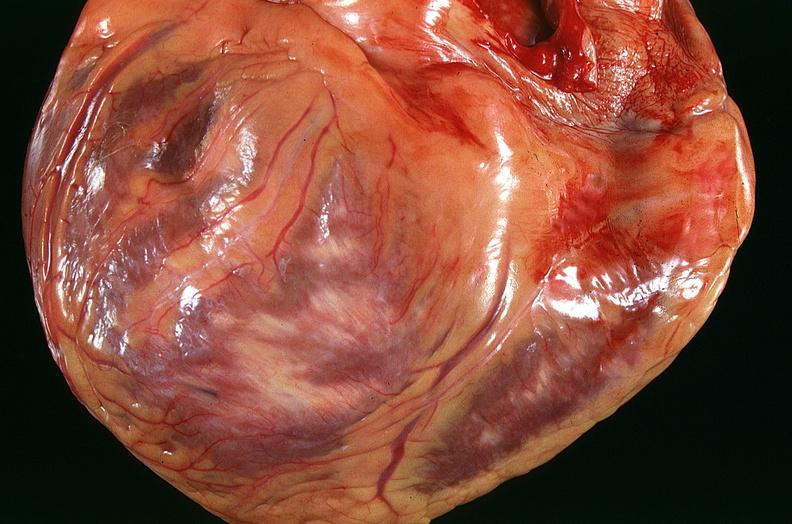s cardiovascular present?
Answer the question using a single word or phrase. Yes 